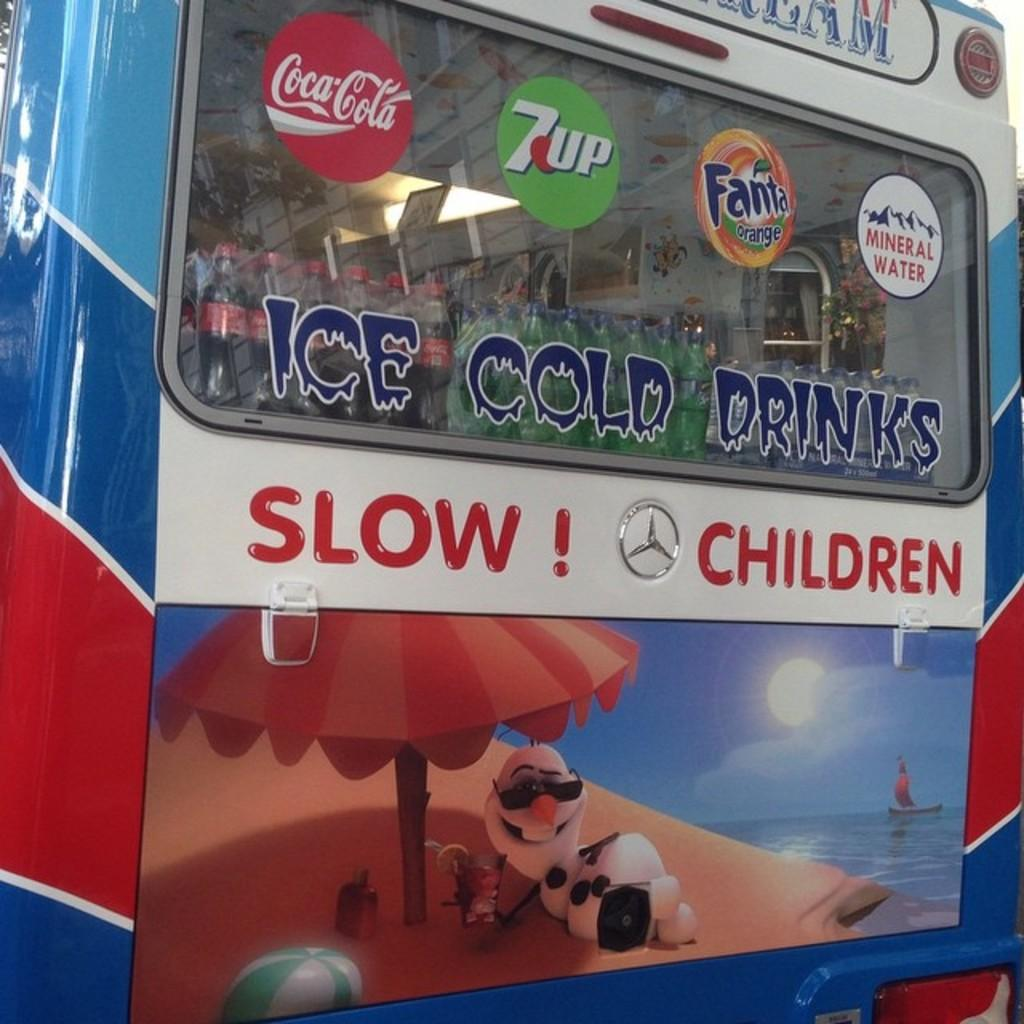What type of vehicle is in the image? There is a van in the image. What can be seen on the van's exterior? The van has text and paintings on it. Where is the mass market located in the image? There is no mass market present in the image; it features a van with text and paintings on it. What type of tray can be seen in the image? There is no tray present in the image. 